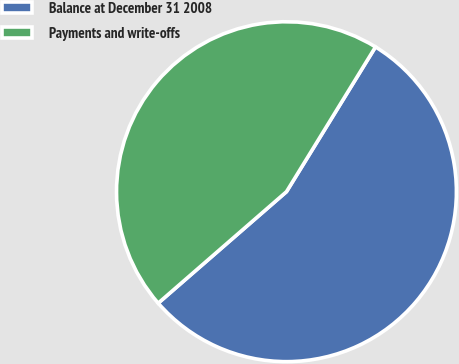Convert chart to OTSL. <chart><loc_0><loc_0><loc_500><loc_500><pie_chart><fcel>Balance at December 31 2008<fcel>Payments and write-offs<nl><fcel>54.84%<fcel>45.16%<nl></chart> 